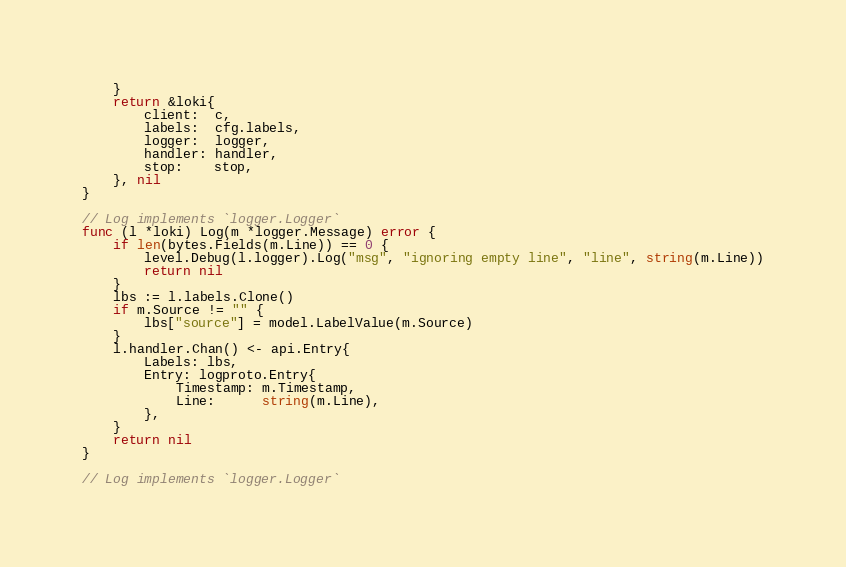<code> <loc_0><loc_0><loc_500><loc_500><_Go_>	}
	return &loki{
		client:  c,
		labels:  cfg.labels,
		logger:  logger,
		handler: handler,
		stop:    stop,
	}, nil
}

// Log implements `logger.Logger`
func (l *loki) Log(m *logger.Message) error {
	if len(bytes.Fields(m.Line)) == 0 {
		level.Debug(l.logger).Log("msg", "ignoring empty line", "line", string(m.Line))
		return nil
	}
	lbs := l.labels.Clone()
	if m.Source != "" {
		lbs["source"] = model.LabelValue(m.Source)
	}
	l.handler.Chan() <- api.Entry{
		Labels: lbs,
		Entry: logproto.Entry{
			Timestamp: m.Timestamp,
			Line:      string(m.Line),
		},
	}
	return nil
}

// Log implements `logger.Logger`</code> 